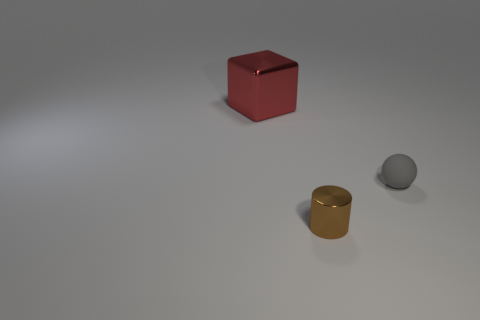Are there any other things that have the same size as the red thing?
Make the answer very short. No. There is a tiny object that is in front of the small rubber sphere; does it have the same color as the metallic thing behind the small matte ball?
Provide a succinct answer. No. What is the small thing behind the shiny thing in front of the thing behind the gray matte object made of?
Ensure brevity in your answer.  Rubber. Is the number of big blue metal balls greater than the number of small metallic cylinders?
Your answer should be very brief. No. Is there any other thing of the same color as the small sphere?
Keep it short and to the point. No. What size is the red block that is made of the same material as the tiny brown cylinder?
Give a very brief answer. Large. What is the material of the block?
Provide a short and direct response. Metal. What number of other metal cylinders have the same size as the shiny cylinder?
Provide a succinct answer. 0. Is there a small gray matte object that has the same shape as the large shiny thing?
Offer a terse response. No. The thing that is the same size as the brown cylinder is what color?
Your response must be concise. Gray. 